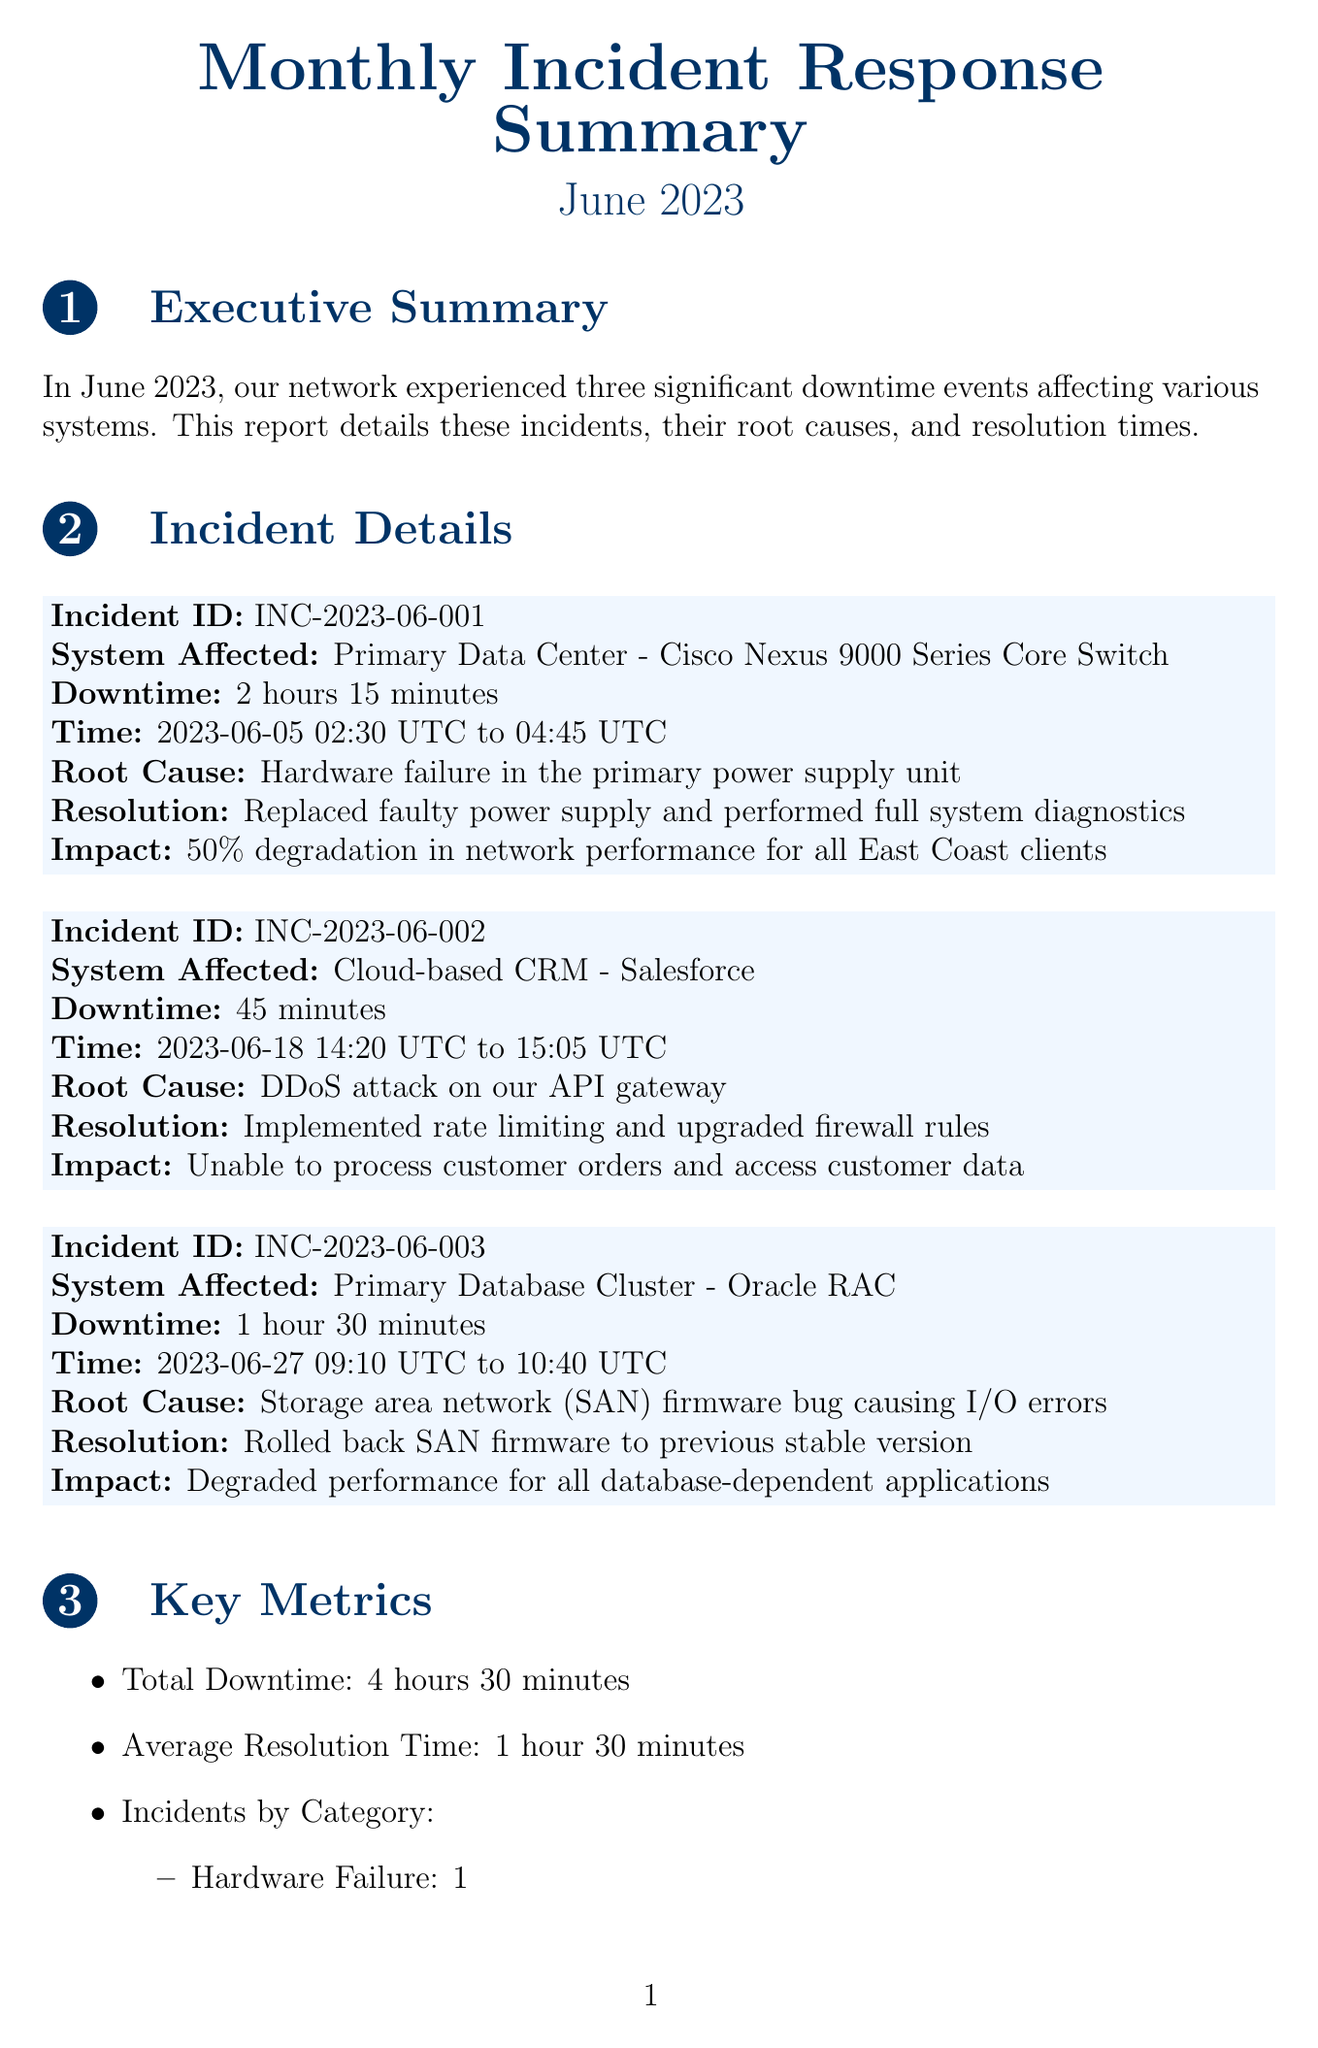What is the total downtime for June 2023? The total downtime is the sum of all individual downtime events listed in the report.
Answer: 4 hours 30 minutes What caused the downtime for the Salesforce system? The document specifies that the root cause of the downtime for Salesforce was due to a DDoS attack on the API gateway.
Answer: DDoS attack When did the incident involving the Cisco Nexus 9000 Series Core Switch occur? The report provides a specific start and end time for the incident involving the Cisco Nexus 9000.
Answer: 2023-06-05 02:30 UTC to 04:45 UTC How long did the downtime last for the Primary Database Cluster? The report includes the downtime duration for the Primary Database Cluster incident, which was stated explicitly.
Answer: 1 hour 30 minutes What mitigation step was taken after the primary power supply failure? The report lists the mitigation steps taken after the incident, specifically related to the power supply issue.
Answer: Implemented redundant power supply configuration What is the average resolution time for the incidents? The average resolution time is calculated based on the total resolution durations provided in the incidents section.
Answer: 1 hour 30 minutes How many incidents were categorized as hardware failures? The document presents a breakdown of incidents by category, which includes counting hardware failures.
Answer: 1 What is an action item listed in the report? The report contains a list of specific action items geared towards improvement after the incidents.
Answer: Conduct a comprehensive review of hardware redundancy across all critical systems What was the impact of the downtime on customer orders in June 2023? The impact section for the Salesforce incident clearly states the effect on customer orders due to downtime.
Answer: Unable to process customer orders and access customer data 